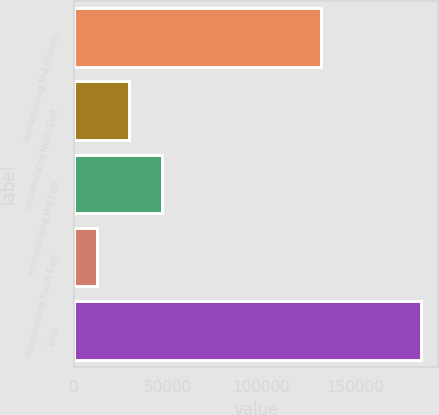Convert chart to OTSL. <chart><loc_0><loc_0><loc_500><loc_500><bar_chart><fcel>Homebuilding Mid Atlantic<fcel>Homebuilding North East<fcel>Homebuilding Mid East<fcel>Homebuilding South East<fcel>Total<nl><fcel>131823<fcel>29576.1<fcel>46835.2<fcel>12317<fcel>184908<nl></chart> 